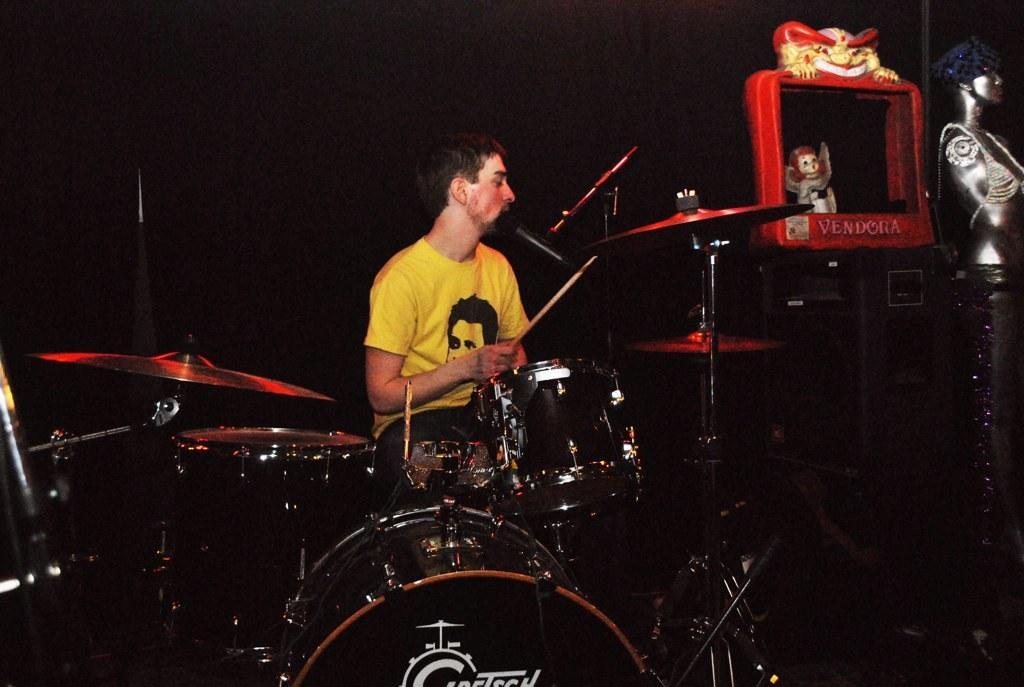Can you describe this image briefly? In this picture we can see a person, he is holding a stick, here we can see musical drums, statue, toy and some objects and in the background we can see it is dark. 